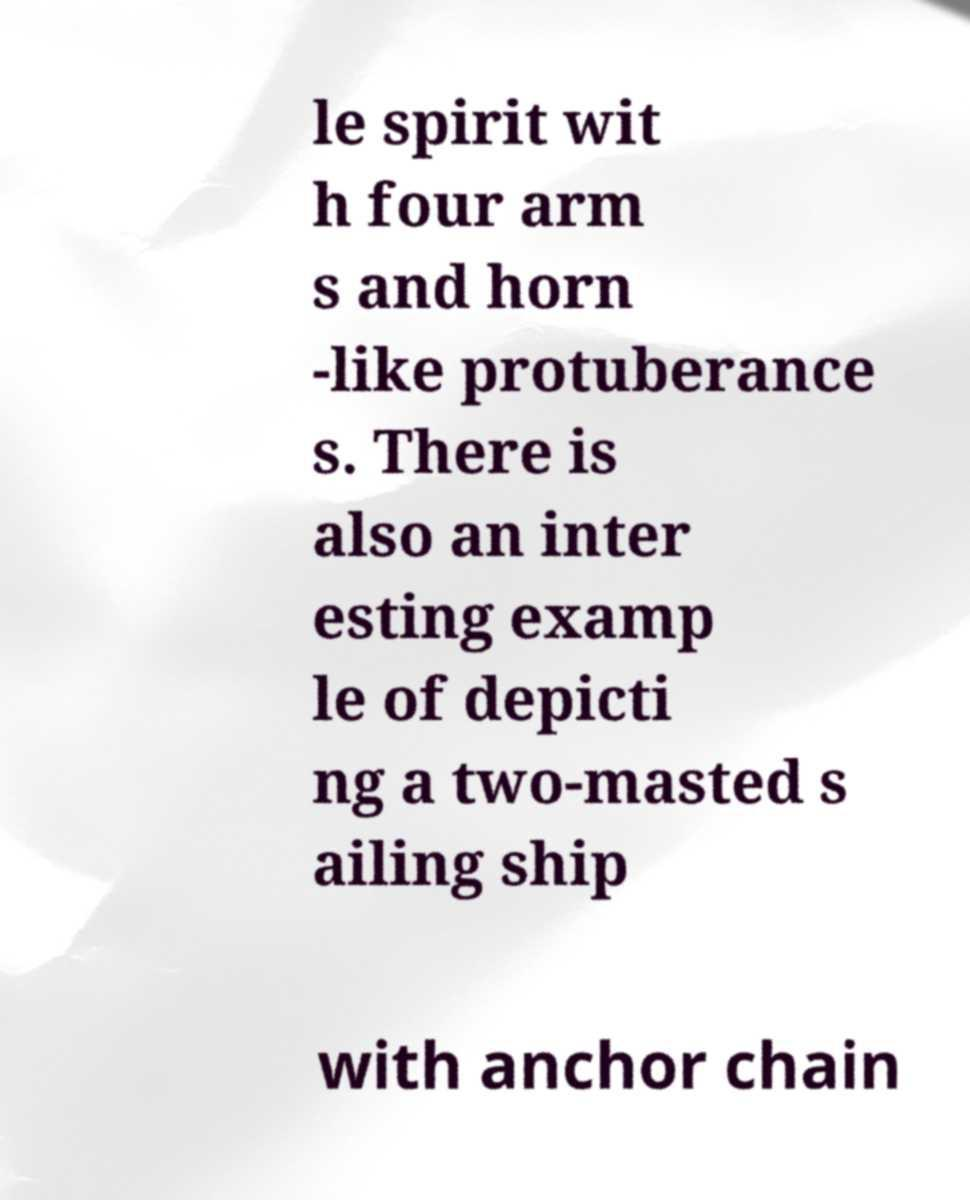I need the written content from this picture converted into text. Can you do that? le spirit wit h four arm s and horn -like protuberance s. There is also an inter esting examp le of depicti ng a two-masted s ailing ship with anchor chain 